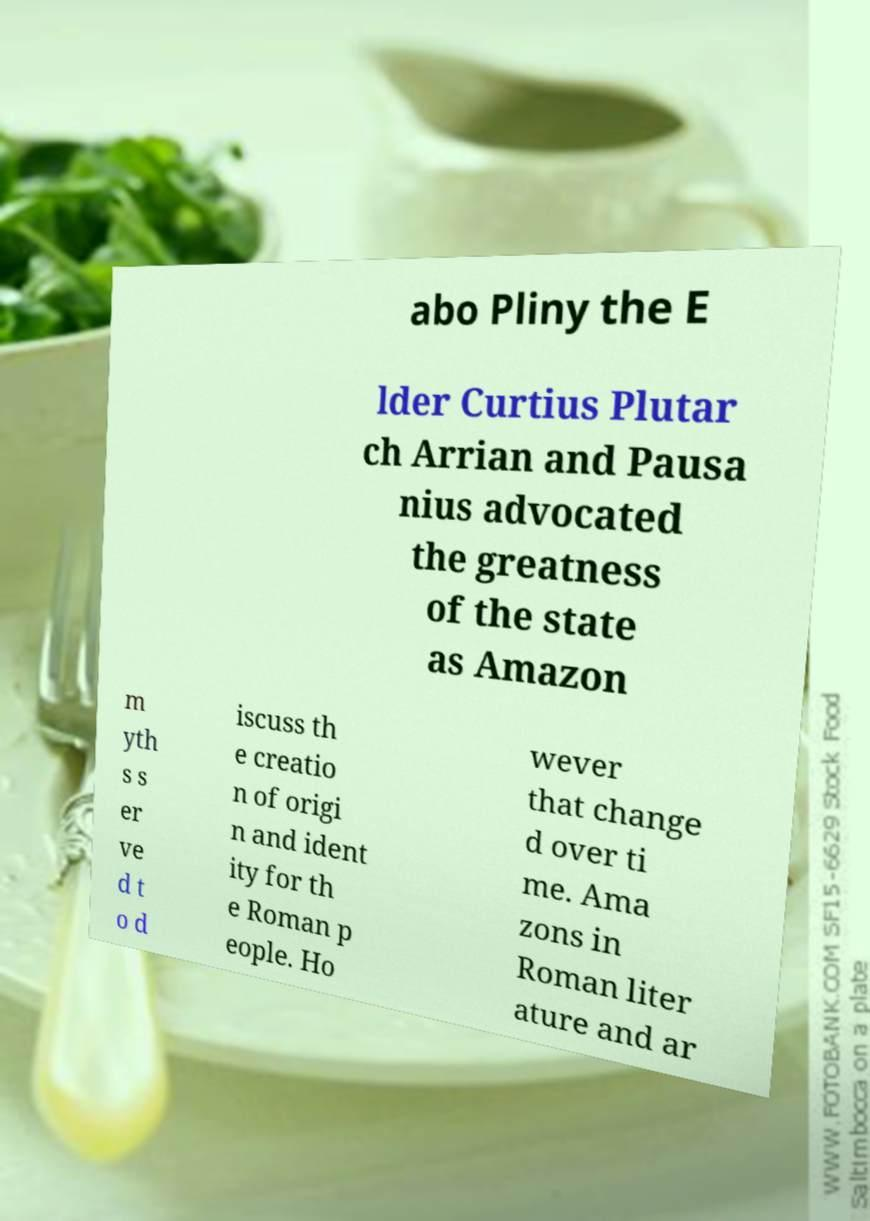For documentation purposes, I need the text within this image transcribed. Could you provide that? abo Pliny the E lder Curtius Plutar ch Arrian and Pausa nius advocated the greatness of the state as Amazon m yth s s er ve d t o d iscuss th e creatio n of origi n and ident ity for th e Roman p eople. Ho wever that change d over ti me. Ama zons in Roman liter ature and ar 